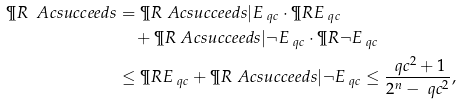Convert formula to latex. <formula><loc_0><loc_0><loc_500><loc_500>\P R { \ A c s u c c e e d s } & = \P R { \ A c s u c c e e d s | E _ { \ q c } } \cdot \P R { E _ { \ q c } } \\ & \quad + \P R { \ A c s u c c e e d s | \neg E _ { \ q c } } \cdot \P R { \neg E _ { \ q c } } \\ & \leq \P R { E _ { \ q c } } + \P R { \ A c s u c c e e d s | \neg E _ { \ q c } } \leq \frac { \ q c ^ { 2 } + 1 } { 2 ^ { n } - \ q c ^ { 2 } } ,</formula> 